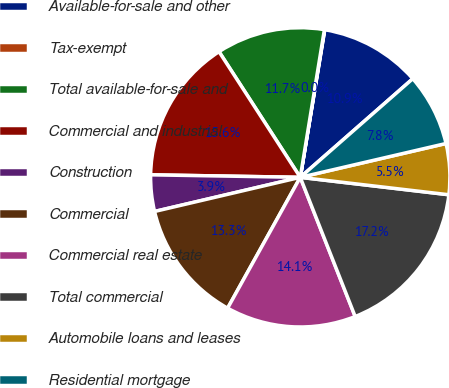Convert chart to OTSL. <chart><loc_0><loc_0><loc_500><loc_500><pie_chart><fcel>Available-for-sale and other<fcel>Tax-exempt<fcel>Total available-for-sale and<fcel>Commercial and industrial<fcel>Construction<fcel>Commercial<fcel>Commercial real estate<fcel>Total commercial<fcel>Automobile loans and leases<fcel>Residential mortgage<nl><fcel>10.93%<fcel>0.04%<fcel>11.71%<fcel>15.6%<fcel>3.93%<fcel>13.27%<fcel>14.05%<fcel>17.16%<fcel>5.49%<fcel>7.82%<nl></chart> 